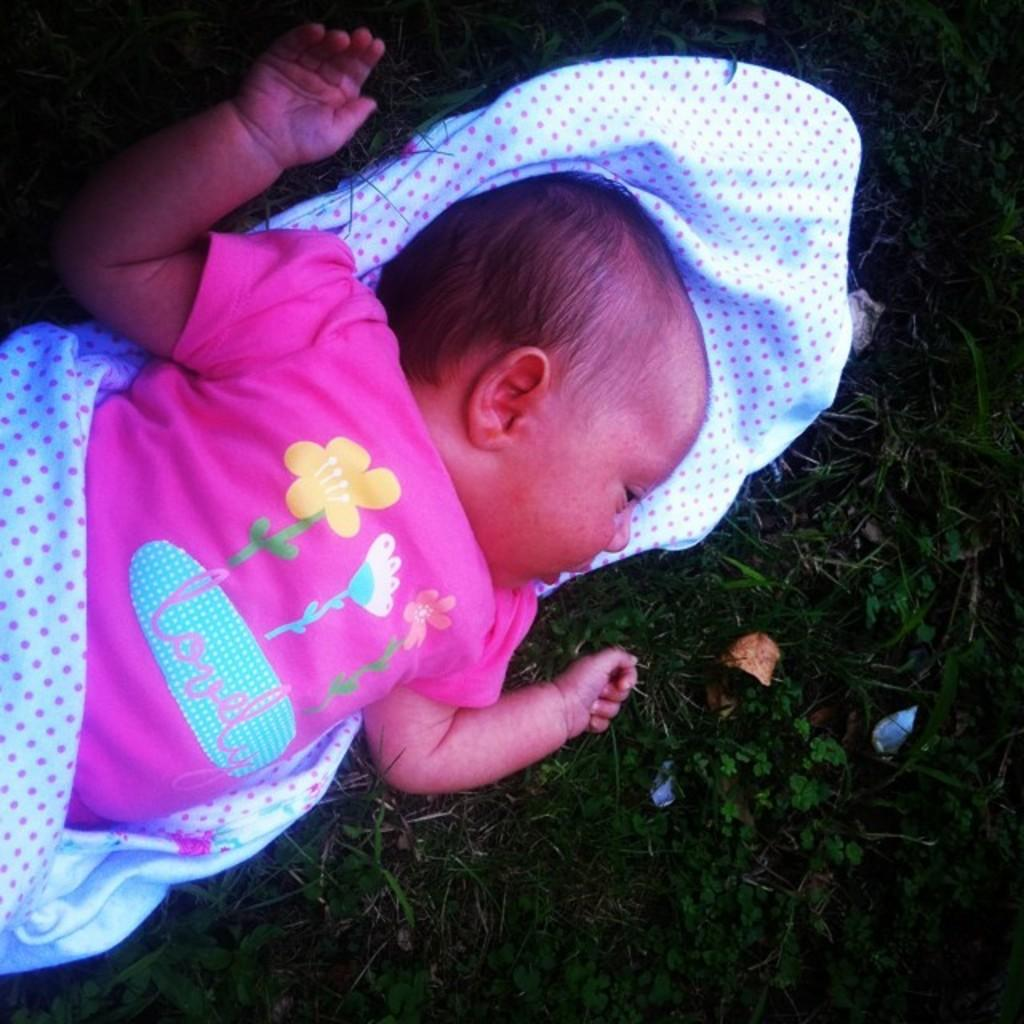What is the main subject of the image? There is a baby in the image. What is the baby wearing? The baby is wearing a pink t-shirt. What type of material can be seen in the image? There is cloth visible in the image. What can be seen in the background of the image? There is grass and a dried leaf in the background of the image. What type of silver band can be seen on the baby's wrist in the image? There is no silver band visible on the baby's wrist in the image. How many times does the baby fold the cloth in the image? The baby is not folding any cloth in the image. 